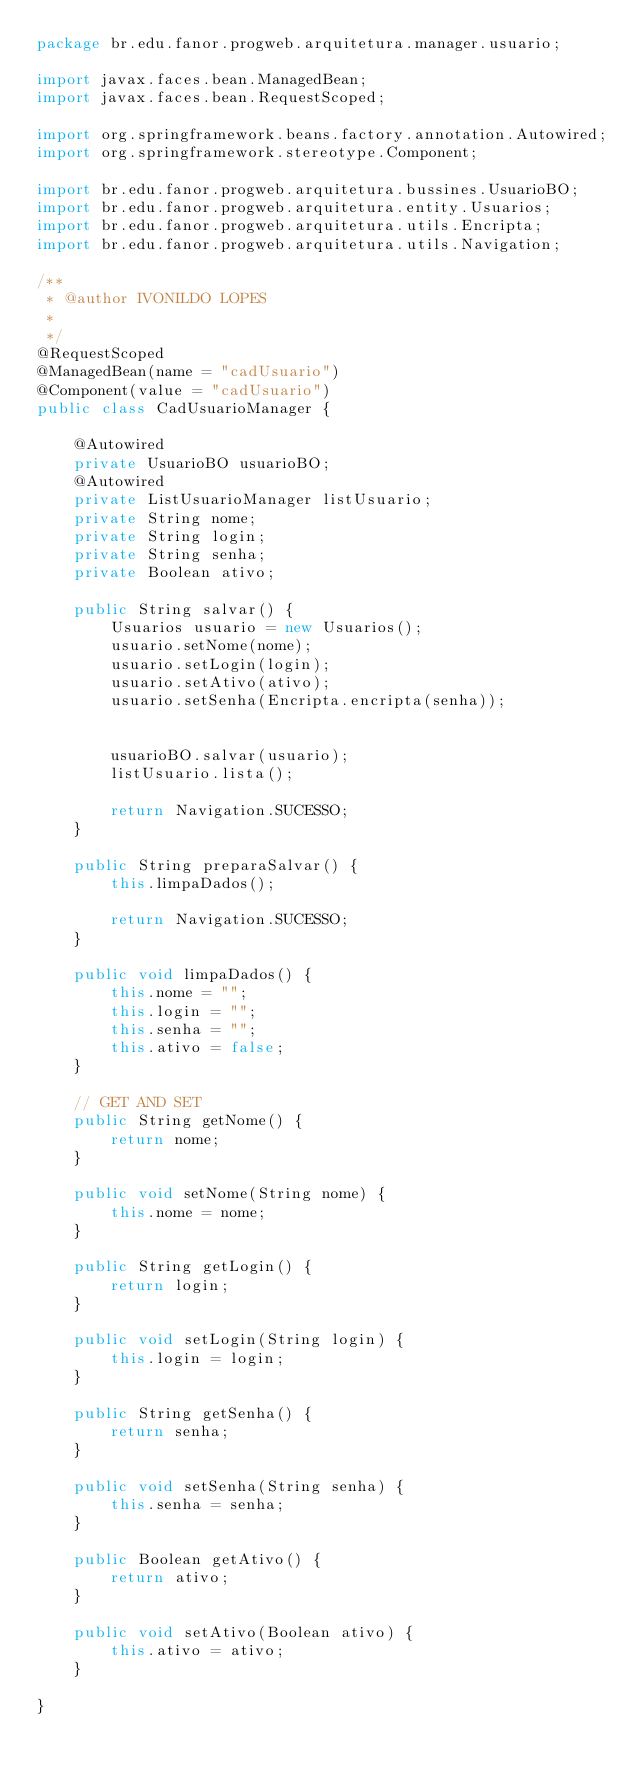Convert code to text. <code><loc_0><loc_0><loc_500><loc_500><_Java_>package br.edu.fanor.progweb.arquitetura.manager.usuario;

import javax.faces.bean.ManagedBean;
import javax.faces.bean.RequestScoped;

import org.springframework.beans.factory.annotation.Autowired;
import org.springframework.stereotype.Component;

import br.edu.fanor.progweb.arquitetura.bussines.UsuarioBO;
import br.edu.fanor.progweb.arquitetura.entity.Usuarios;
import br.edu.fanor.progweb.arquitetura.utils.Encripta;
import br.edu.fanor.progweb.arquitetura.utils.Navigation;

/**
 * @author IVONILDO LOPES
 * 
 */
@RequestScoped
@ManagedBean(name = "cadUsuario")
@Component(value = "cadUsuario")
public class CadUsuarioManager {

	@Autowired
	private UsuarioBO usuarioBO;
	@Autowired
	private ListUsuarioManager listUsuario;
	private String nome;
	private String login;
	private String senha;
	private Boolean ativo;

	public String salvar() {
		Usuarios usuario = new Usuarios();
		usuario.setNome(nome);
		usuario.setLogin(login);
		usuario.setAtivo(ativo);
		usuario.setSenha(Encripta.encripta(senha));
		

		usuarioBO.salvar(usuario);
		listUsuario.lista();

		return Navigation.SUCESSO;
	}

	public String preparaSalvar() {
		this.limpaDados();

		return Navigation.SUCESSO;
	}

	public void limpaDados() {
		this.nome = "";
		this.login = "";
		this.senha = "";
		this.ativo = false;
	}

	// GET AND SET
	public String getNome() {
		return nome;
	}

	public void setNome(String nome) {
		this.nome = nome;
	}

	public String getLogin() {
		return login;
	}

	public void setLogin(String login) {
		this.login = login;
	}

	public String getSenha() {
		return senha;
	}

	public void setSenha(String senha) {
		this.senha = senha;
	}

	public Boolean getAtivo() {
		return ativo;
	}

	public void setAtivo(Boolean ativo) {
		this.ativo = ativo;
	}

}
</code> 